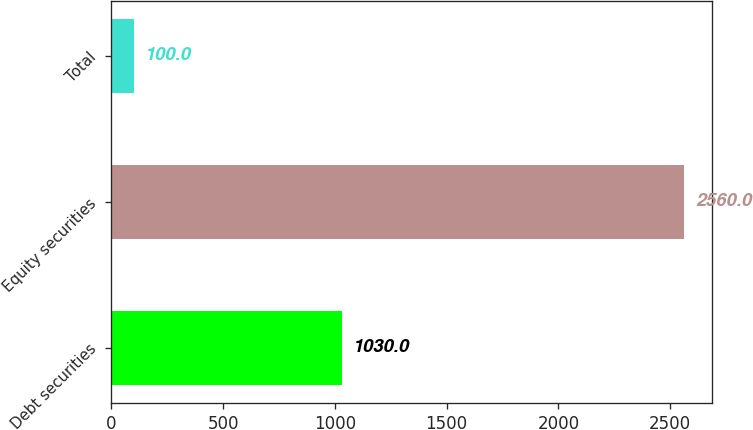Convert chart to OTSL. <chart><loc_0><loc_0><loc_500><loc_500><bar_chart><fcel>Debt securities<fcel>Equity securities<fcel>Total<nl><fcel>1030<fcel>2560<fcel>100<nl></chart> 